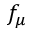Convert formula to latex. <formula><loc_0><loc_0><loc_500><loc_500>f _ { \mu }</formula> 